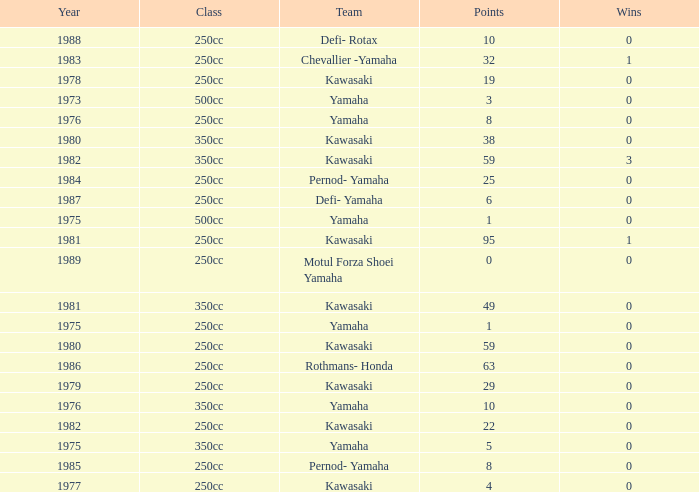Which highest wins number had Kawasaki as a team, 95 points, and a year prior to 1981? None. 